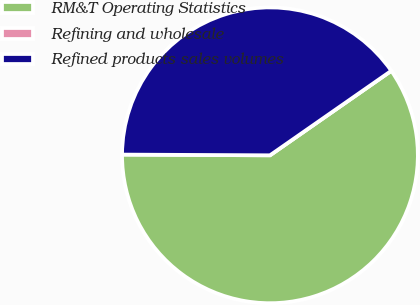<chart> <loc_0><loc_0><loc_500><loc_500><pie_chart><fcel>RM&T Operating Statistics<fcel>Refining and wholesale<fcel>Refined products sales volumes<nl><fcel>59.76%<fcel>0.0%<fcel>40.24%<nl></chart> 